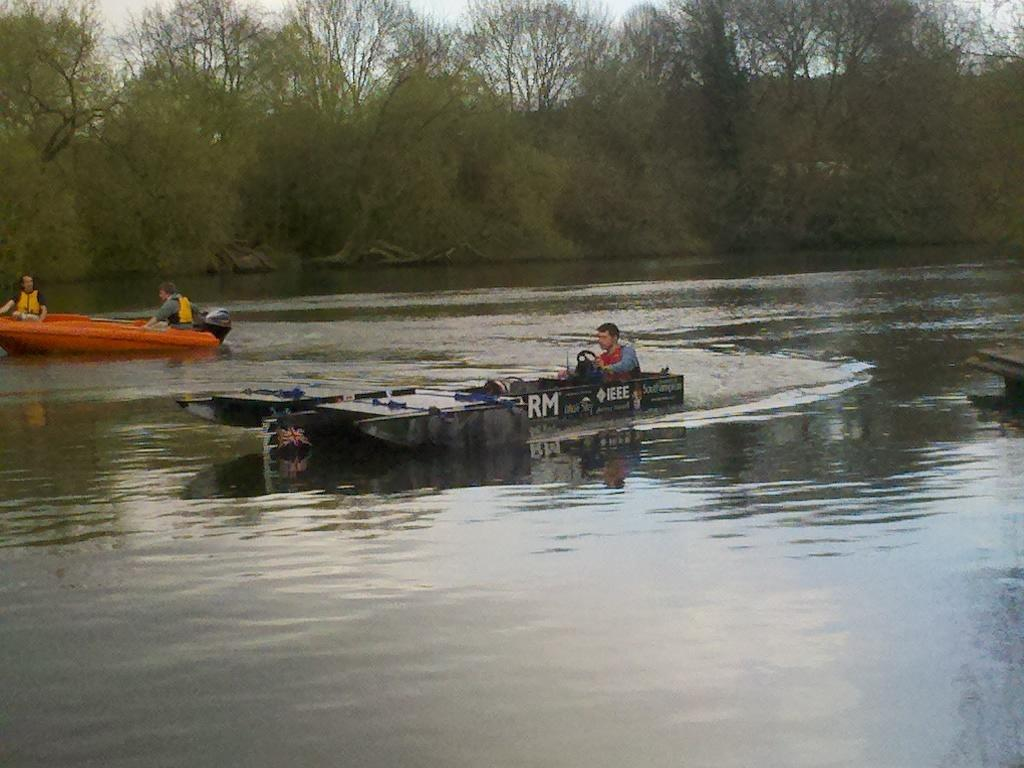How many people are in the image? There are three persons in the image. What are the persons doing in the image? The persons are boating in the water. What can be seen in the background of the image? There are trees and the sky visible in the background of the image. Where might this image have been taken? The image may have been taken at a lake, given the presence of water and trees. How much money can be seen in the image? There is no money visible in the image; it features three persons boating in the water. Is there a cow present in the image? No, there is no cow present in the image. 